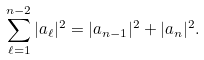Convert formula to latex. <formula><loc_0><loc_0><loc_500><loc_500>\sum _ { \ell = 1 } ^ { n - 2 } | a _ { \ell } | ^ { 2 } = | a _ { n - 1 } | ^ { 2 } + | a _ { n } | ^ { 2 } .</formula> 